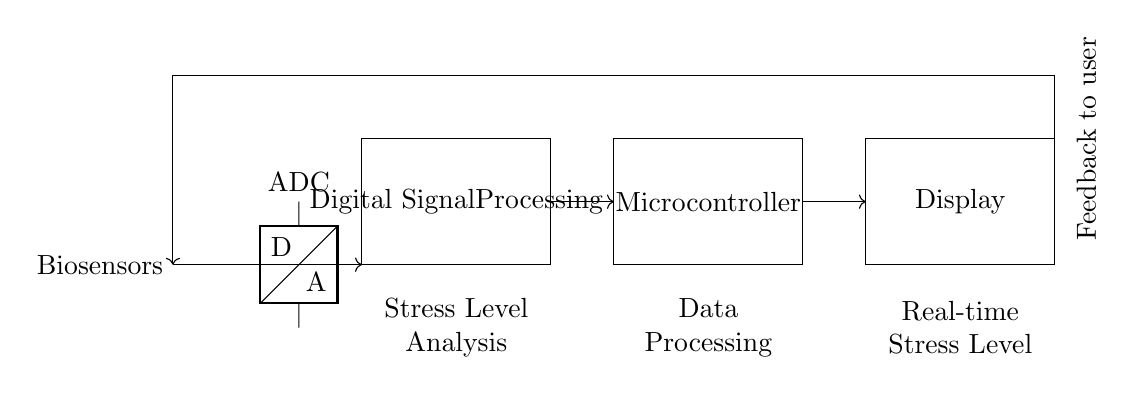What type of sensors are used in this circuit? The circuit diagram indicates a "Biosensors" component as the input, suggesting that this system employs biosensors to monitor stress levels.
Answer: Biosensors What is the function of the ADC in the circuit? The ADC, or Analog-to-Digital Converter, in this circuit transforms the analog signals from the biosensors into digital data that can be processed in the digital signal processing unit.
Answer: Convert signals What does the Digital Signal Processing block do? The Digital Signal Processing block is responsible for analyzing the stress levels based on the data received from the ADC, interpreting the signals, and preparing data for further use.
Answer: Stress Level Analysis What is the ultimate output of the system? The output of the system is displayed in real-time on the connected display, which presents processed stress levels to the user.
Answer: Real-time Stress Level How is feedback provided to the user? Feedback is provided through a loop that connects from the display back to the biosensors, indicating that the system continuously updates the user about their stress levels during the monitoring process.
Answer: Feedback loop What component connects the digital processing to the display? The Microcontroller serves as the intermediary component that connects the digital signal processing unit to the display, allowing for processed information to be presented visually.
Answer: Microcontroller 